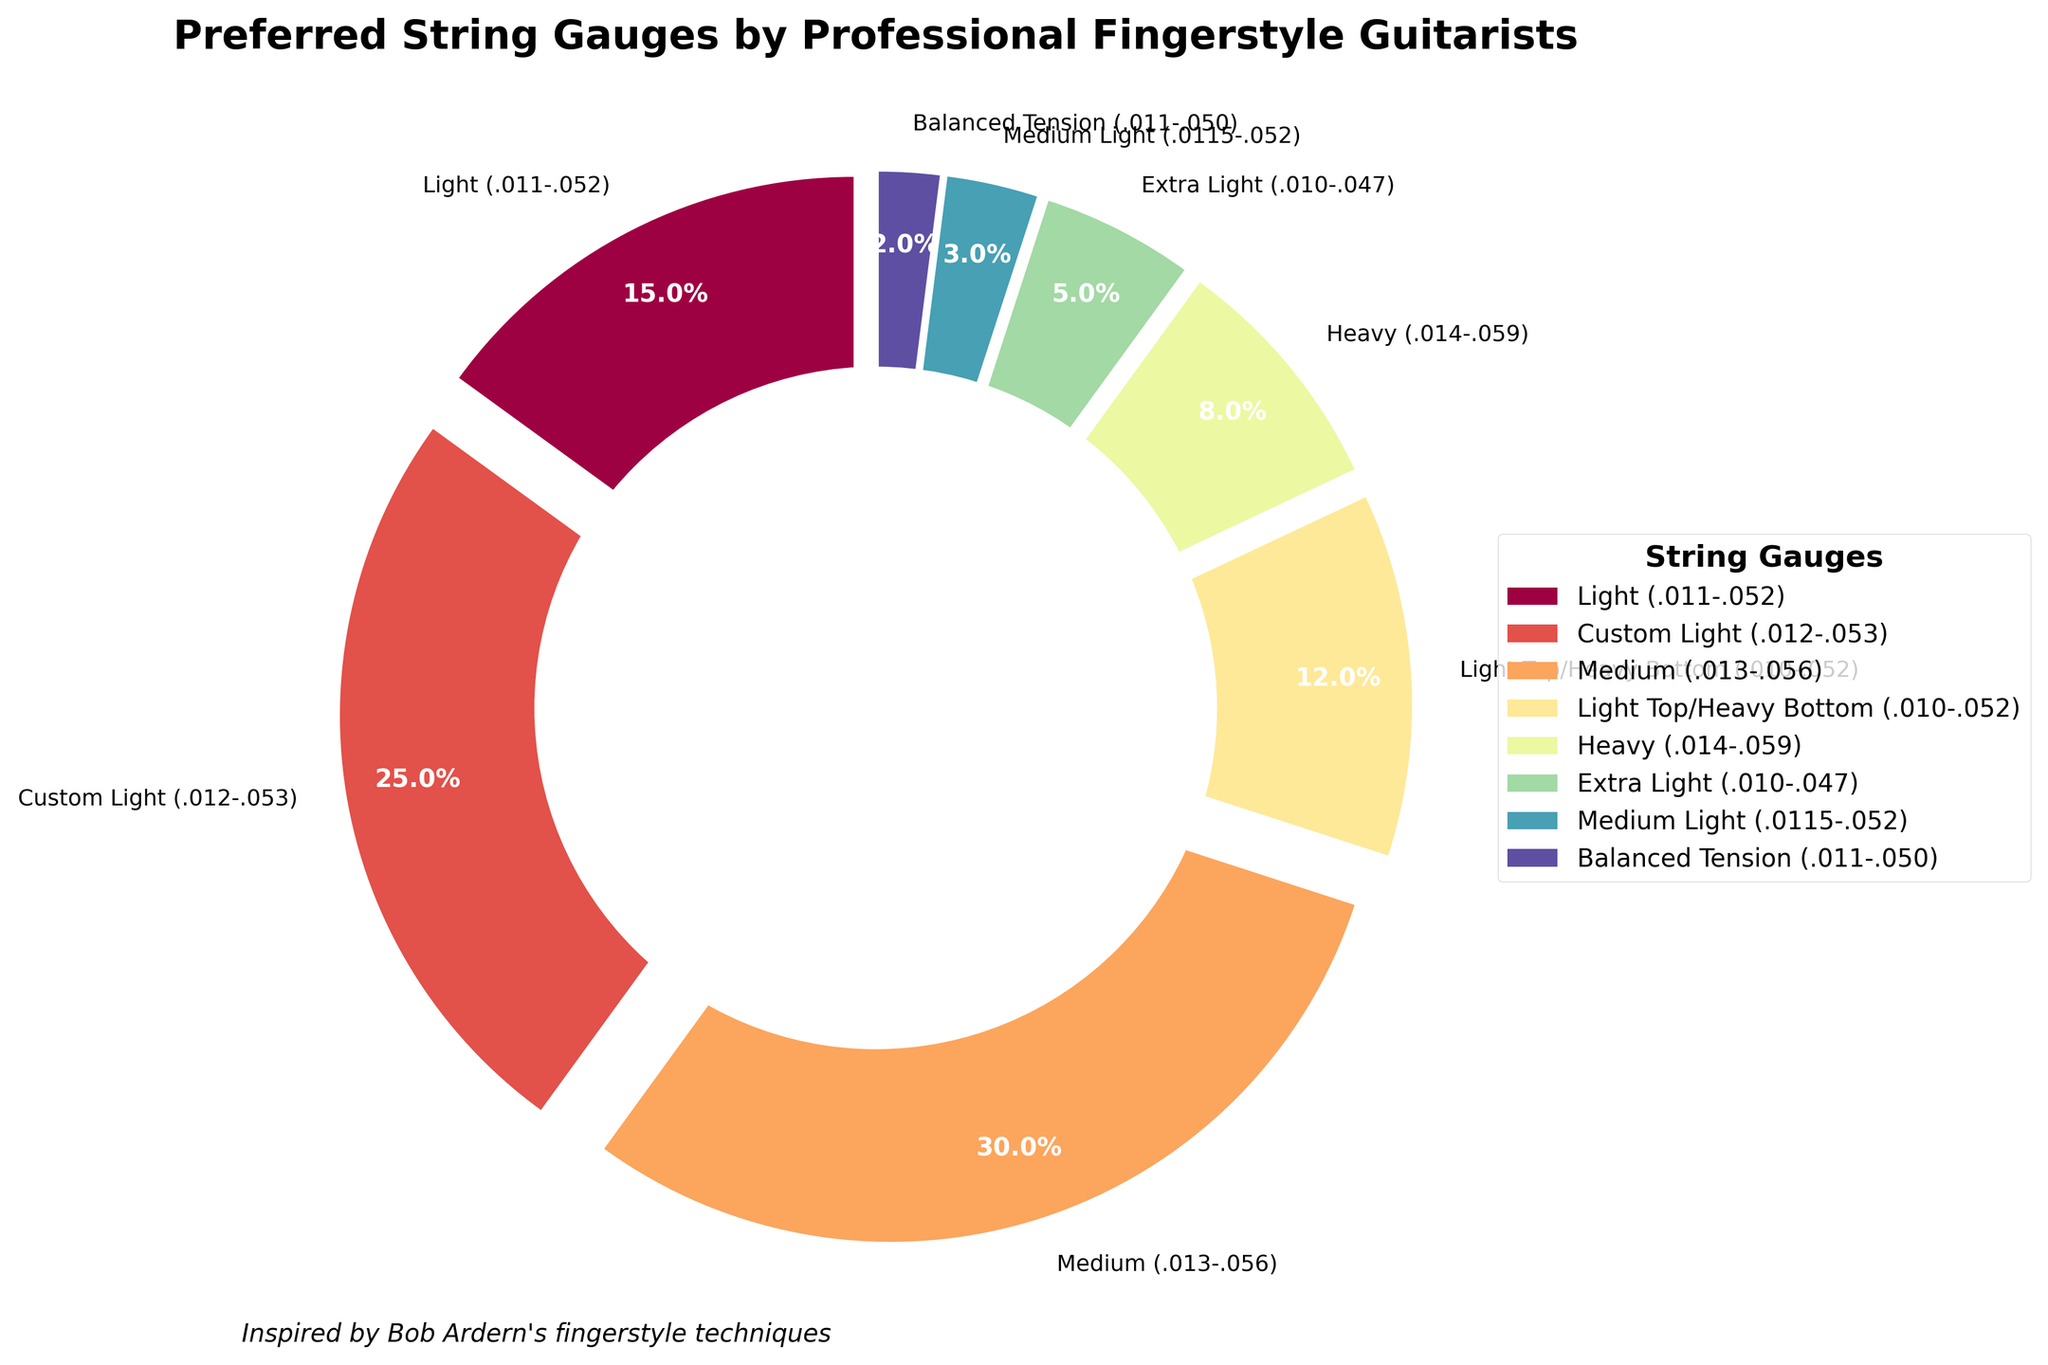Which string gauge is the most preferred by professional fingerstyle guitarists? The Medium (.013-.056) gauge segment has the largest portion of the pie chart, indicating it is the most preferred string gauge among professional fingerstyle guitarists.
Answer: Medium (.013-.056) How many string gauges have a preference percentage of 10% or more? From the pie chart, the string gauges with a preference percentage of 10% or more are: Medium (.013-.056), Custom Light (.012-.053), and Light (.011-.052), and Light Top/Heavy Bottom (.010-.052).
Answer: 4 What is the combined preference percentage for Light (.011-.052) and Custom Light (.012-.053) gauges? The Light (.011-.052) gauge has a 15% preference, and the Custom Light (.012-.053) gauge has a 25% preference. Adding these two percentages together gives 15% + 25% = 40%.
Answer: 40% Which string gauge has the least preference among professional fingerstyle guitarists? The Balanced Tension (.011-.050) gauge slice is the smallest segment on the pie chart, indicating it has the least preference.
Answer: Balanced Tension (.011-.050) Comparing Heavy (.014-.059) and Extra Light (.010-.047) gauges, which is more preferred and by what percentage difference? Heavy (.014-.059) has an 8% preference, and Extra Light (.010-.047) has a 5% preference. The difference is 8% - 5% = 3%.
Answer: Heavy (.014-.059), 3% What percentage of professional fingerstyle guitarists prefer a string gauge heavier than Custom Light (.012-.053)? The string gauges heavier than Custom Light (.012-.053) are Medium (.013-.056) and Heavy (.014-.059). Their percentages are 30% and 8% respectively, giving a total of 30% + 8% = 38%.
Answer: 38% How does the preference for Light (.011-.052) gauges compare to that for Heavy (.014-.059) gauges? The preference for Light (.011-.052) gauges is 15%, whereas for Heavy (.014-.059) gauges, it is 8%. Thus, Light gauges are preferred 7% more than Heavy gauges.
Answer: 7% Which color is used to represent the Light Top/Heavy Bottom (.010-.052) gauge in the pie chart? The Light Top/Heavy Bottom (.010-.052) gauge segment is represented by a specific color in the pie chart. Checking the legend and corresponding slice of the Light Top/Heavy Bottom (.010-.052) will reveal the color.
Answer: (Identify visually based on the color in the chart) 